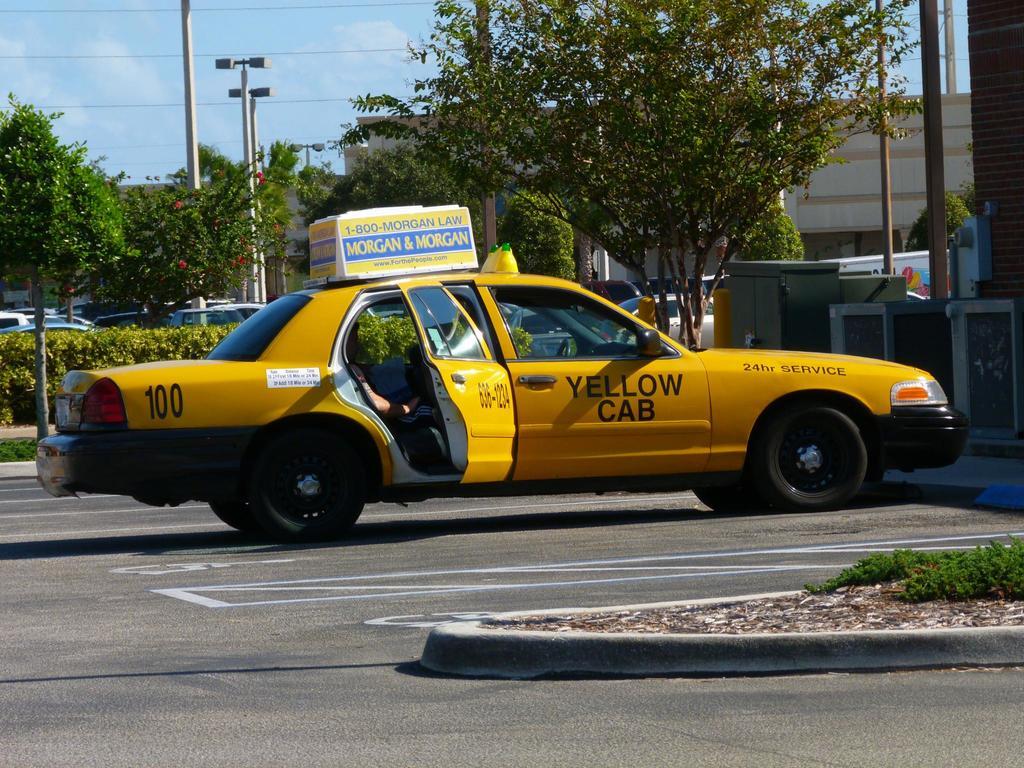What color is the cab?
Provide a short and direct response. Yellow. What is the number of this cab?
Provide a short and direct response. 100. 